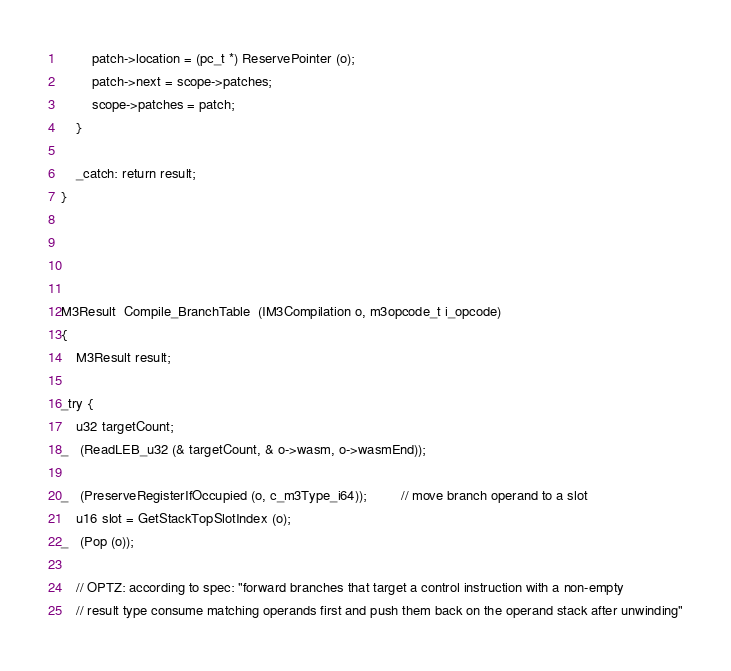Convert code to text. <code><loc_0><loc_0><loc_500><loc_500><_C_>
        patch->location = (pc_t *) ReservePointer (o);
        patch->next = scope->patches;
        scope->patches = patch;
    }

    _catch: return result;
}




M3Result  Compile_BranchTable  (IM3Compilation o, m3opcode_t i_opcode)
{
    M3Result result;

_try {
    u32 targetCount;
_   (ReadLEB_u32 (& targetCount, & o->wasm, o->wasmEnd));

_   (PreserveRegisterIfOccupied (o, c_m3Type_i64));         // move branch operand to a slot
    u16 slot = GetStackTopSlotIndex (o);
_   (Pop (o));

    // OPTZ: according to spec: "forward branches that target a control instruction with a non-empty
    // result type consume matching operands first and push them back on the operand stack after unwinding"</code> 